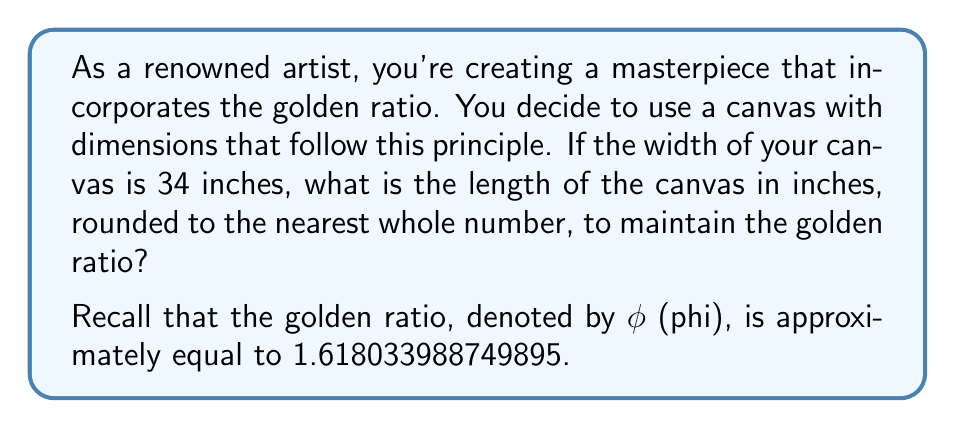Teach me how to tackle this problem. To solve this problem, we'll use the properties of the golden ratio and basic algebra:

1) The golden ratio φ is defined as the ratio of the longer side to the shorter side. In this case:

   $\frac{\text{length}}{\text{width}} = φ$

2) We know the width is 34 inches and φ ≈ 1.618033988749895. Let's call the length x. We can set up the equation:

   $\frac{x}{34} = 1.618033988749895$

3) To solve for x, multiply both sides by 34:

   $x = 34 * 1.618033988749895$

4) Now, let's calculate:

   $x = 55.01315561749643$

5) Rounding to the nearest whole number:

   $x ≈ 55$

Therefore, the length of the canvas should be approximately 55 inches to maintain the golden ratio with a width of 34 inches.
Answer: 55 inches 